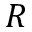<formula> <loc_0><loc_0><loc_500><loc_500>R</formula> 